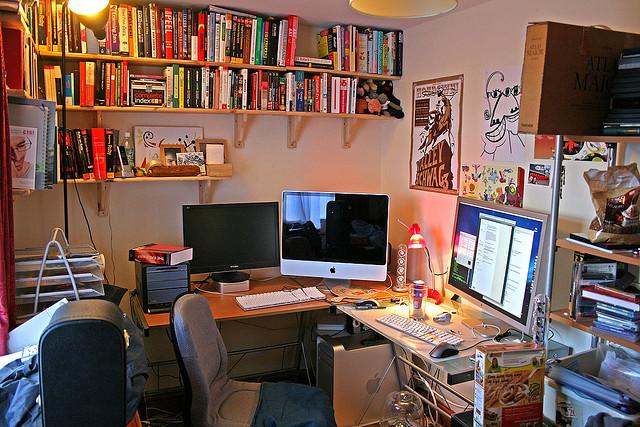Is there a television on the desk?
Answer briefly. No. Where are the books placed?
Keep it brief. Shelves. Is the computer on?
Answer briefly. Yes. Is anything directly written or drawn on the walls?
Be succinct. No. What type of lighting is there?
Quick response, please. Lamps. 